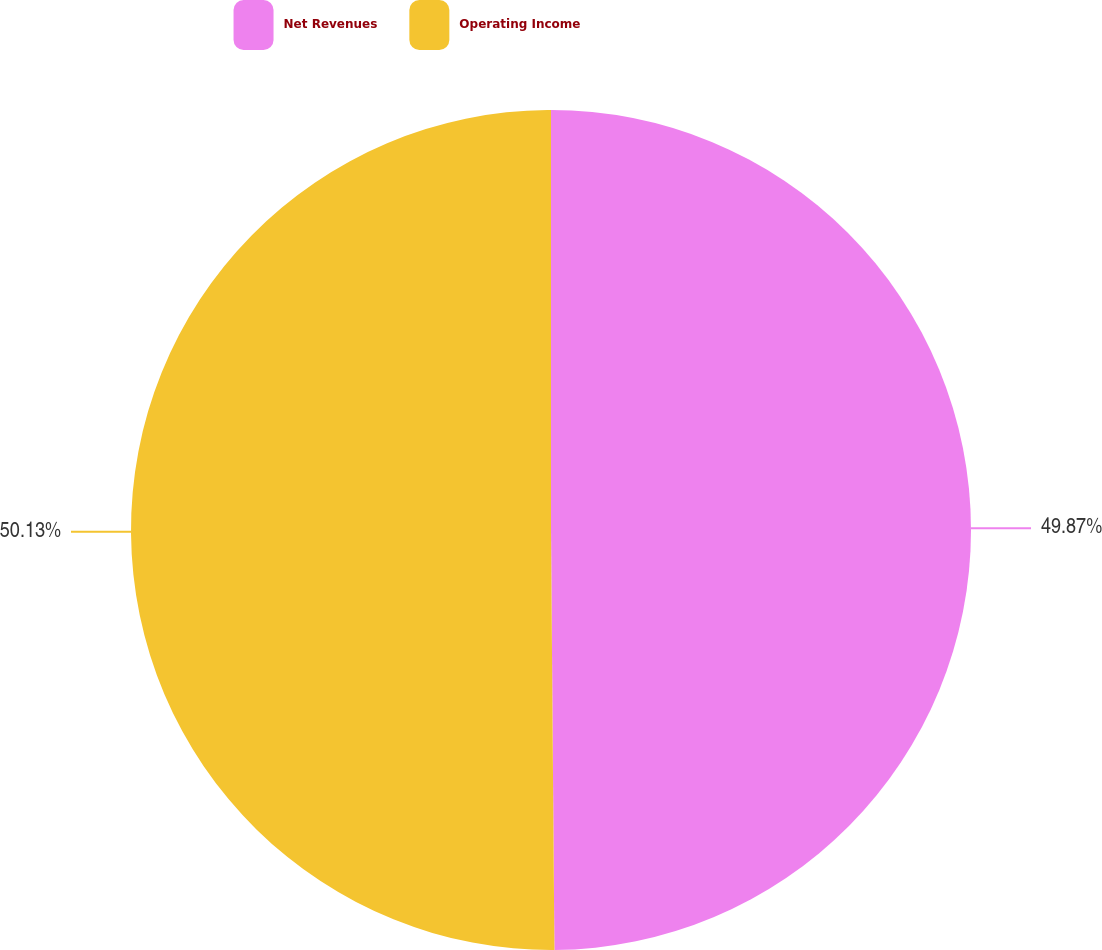<chart> <loc_0><loc_0><loc_500><loc_500><pie_chart><fcel>Net Revenues<fcel>Operating Income<nl><fcel>49.87%<fcel>50.13%<nl></chart> 